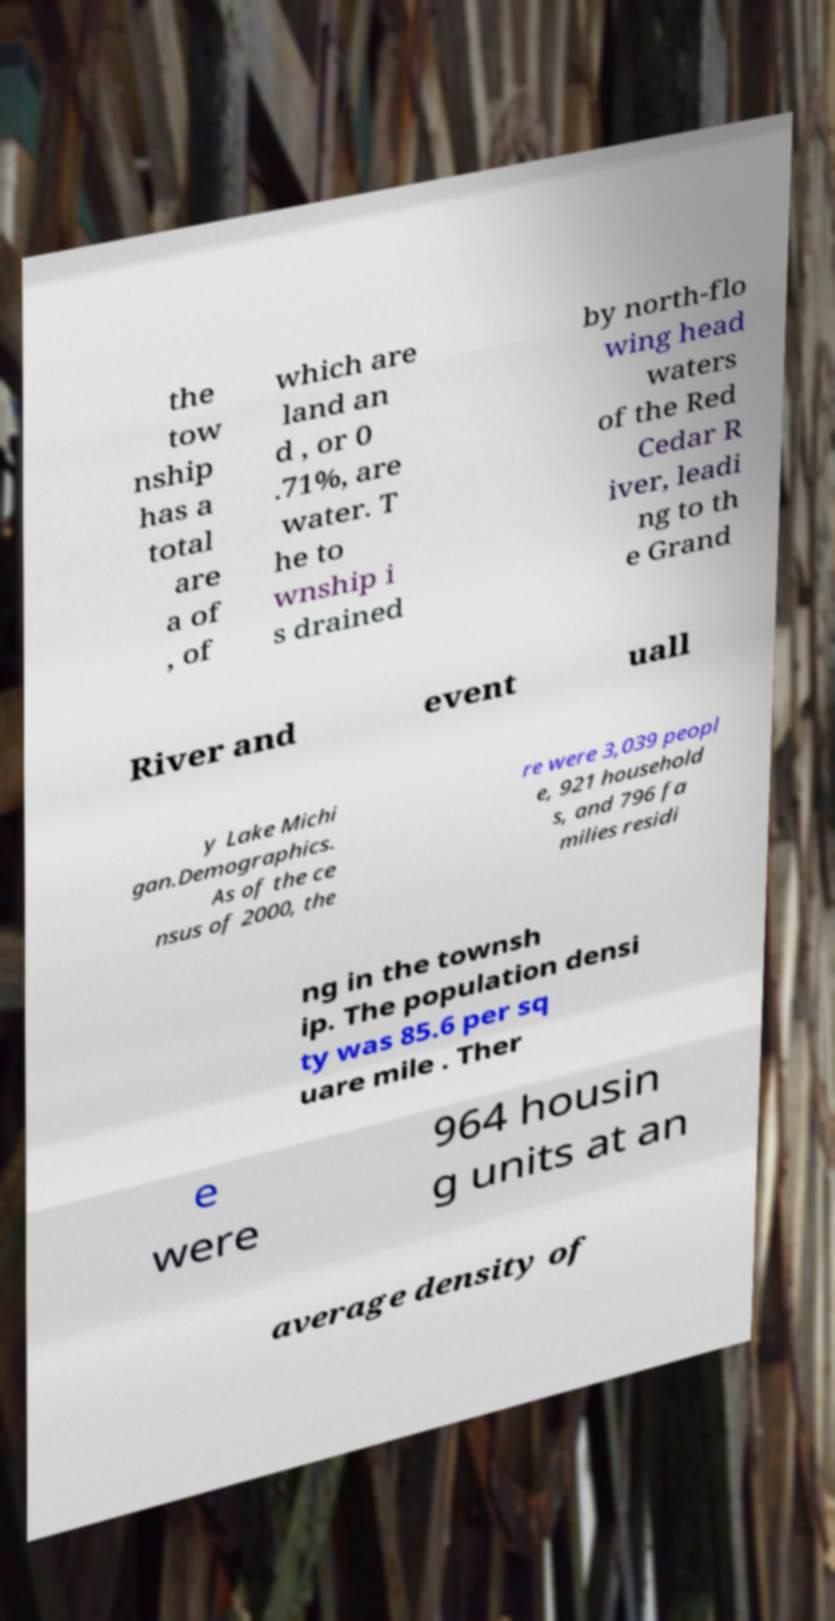There's text embedded in this image that I need extracted. Can you transcribe it verbatim? the tow nship has a total are a of , of which are land an d , or 0 .71%, are water. T he to wnship i s drained by north-flo wing head waters of the Red Cedar R iver, leadi ng to th e Grand River and event uall y Lake Michi gan.Demographics. As of the ce nsus of 2000, the re were 3,039 peopl e, 921 household s, and 796 fa milies residi ng in the townsh ip. The population densi ty was 85.6 per sq uare mile . Ther e were 964 housin g units at an average density of 